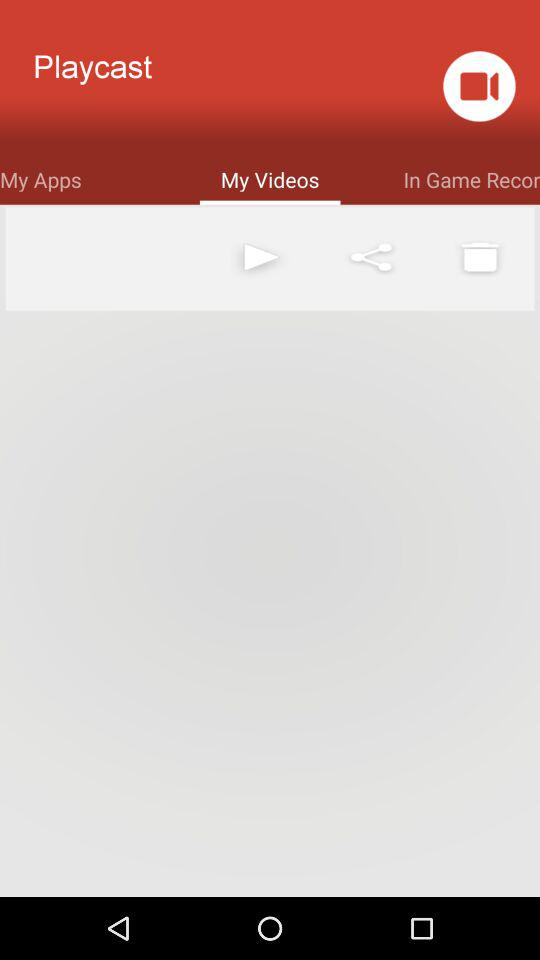Which option has been selected? The option that has been selected is "My Videos". 